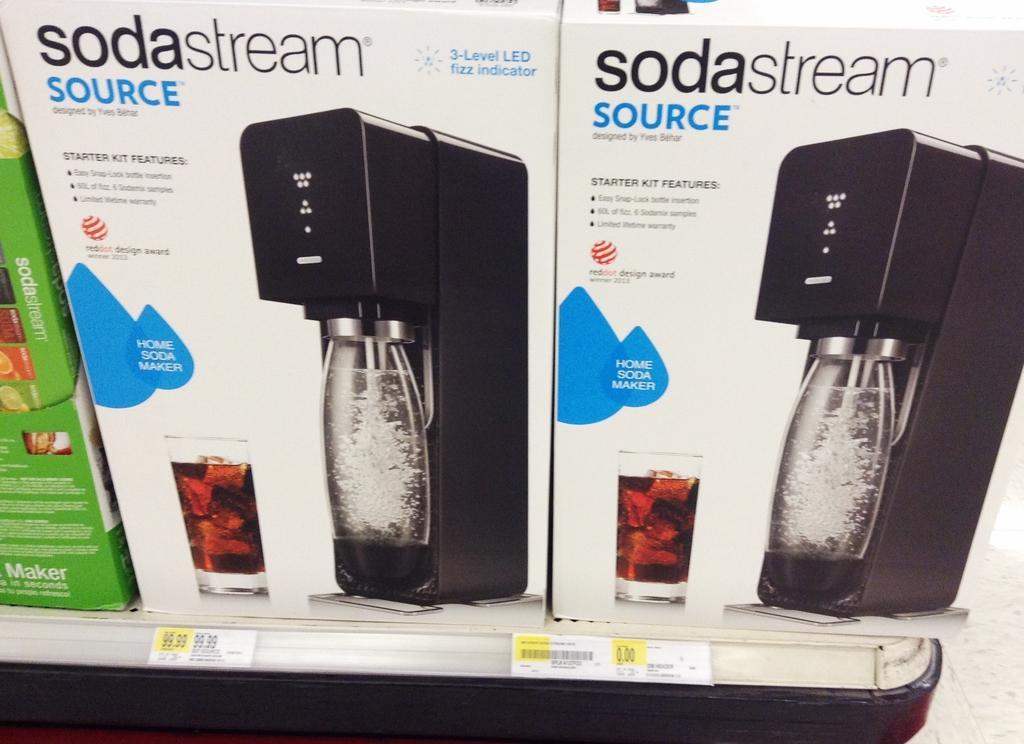Can you describe this image briefly? In this picture I can see 3 boxes in front, on which there is something written and I see the depiction of 2 glasses, 2 machines and 2 jars and I can see the price tags. 